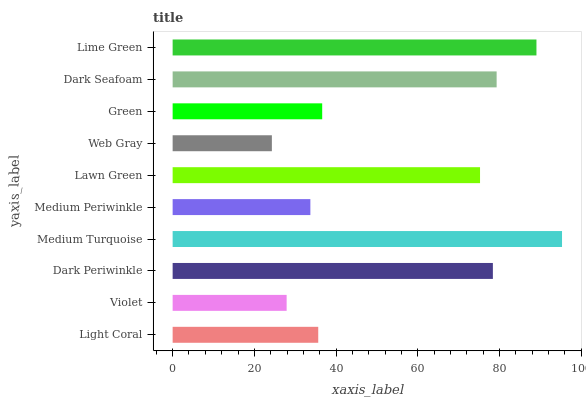Is Web Gray the minimum?
Answer yes or no. Yes. Is Medium Turquoise the maximum?
Answer yes or no. Yes. Is Violet the minimum?
Answer yes or no. No. Is Violet the maximum?
Answer yes or no. No. Is Light Coral greater than Violet?
Answer yes or no. Yes. Is Violet less than Light Coral?
Answer yes or no. Yes. Is Violet greater than Light Coral?
Answer yes or no. No. Is Light Coral less than Violet?
Answer yes or no. No. Is Lawn Green the high median?
Answer yes or no. Yes. Is Green the low median?
Answer yes or no. Yes. Is Medium Periwinkle the high median?
Answer yes or no. No. Is Medium Turquoise the low median?
Answer yes or no. No. 